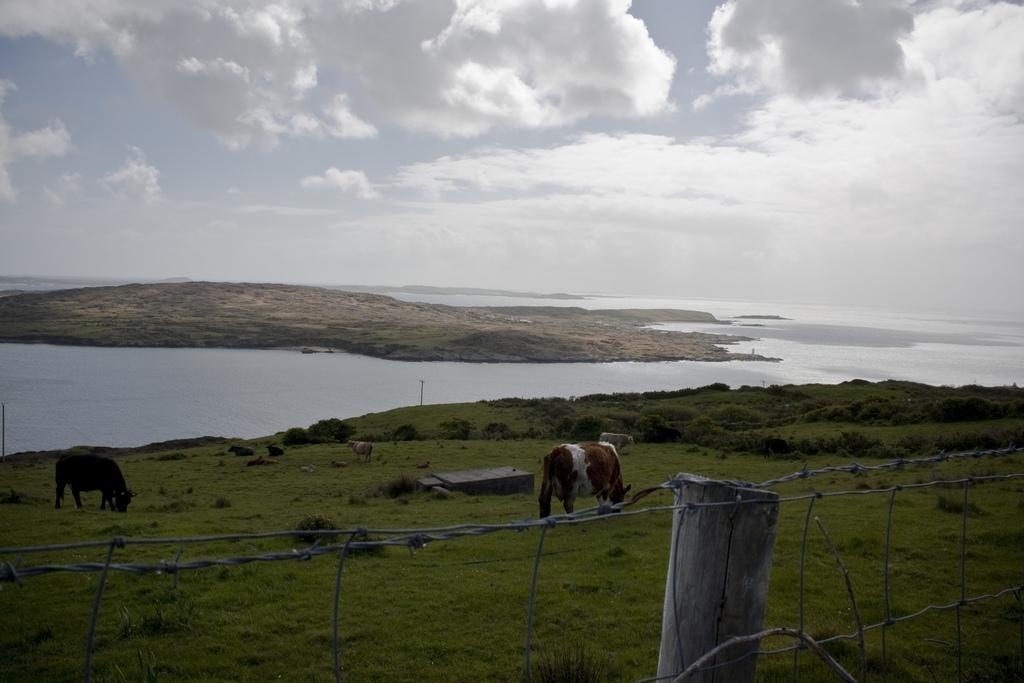Describe this image in one or two sentences. In this picture, i can see water and few cows are seated and couple of them are grazing grass and i can see fence and grass on the ground and few plants and a cloudy Sky. 